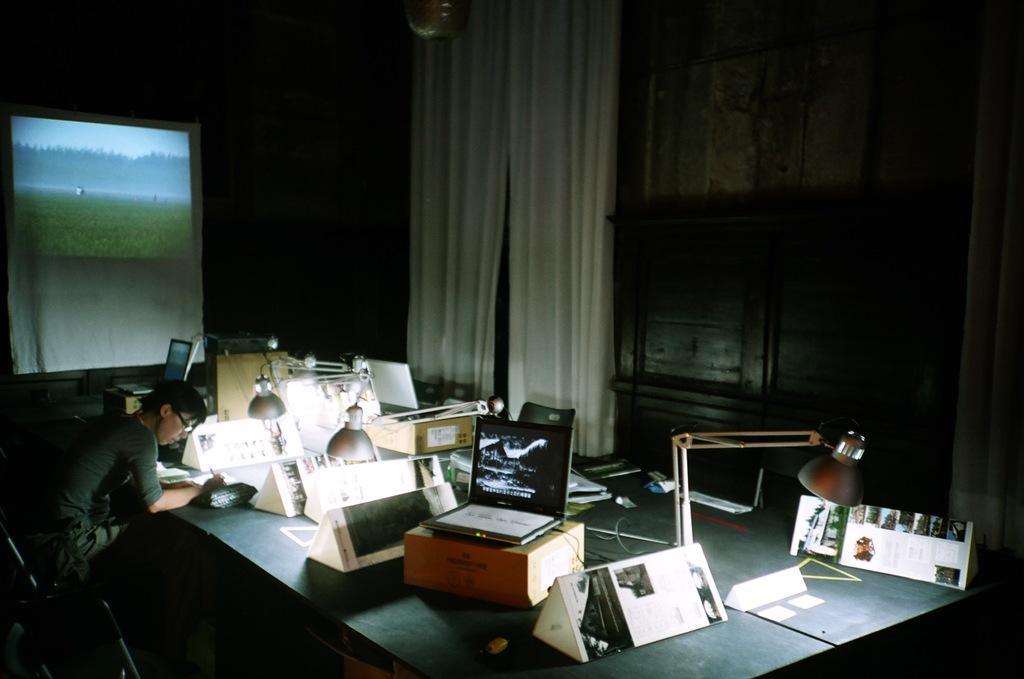Describe this image in one or two sentences. In this image we can see a man is sitting and he is wearing t-shirt. In front of him one table is there. On table boxes, table light, laptop, files and Triangular shaped things are present. Background of the image curtain, cupboard and screen is present. 